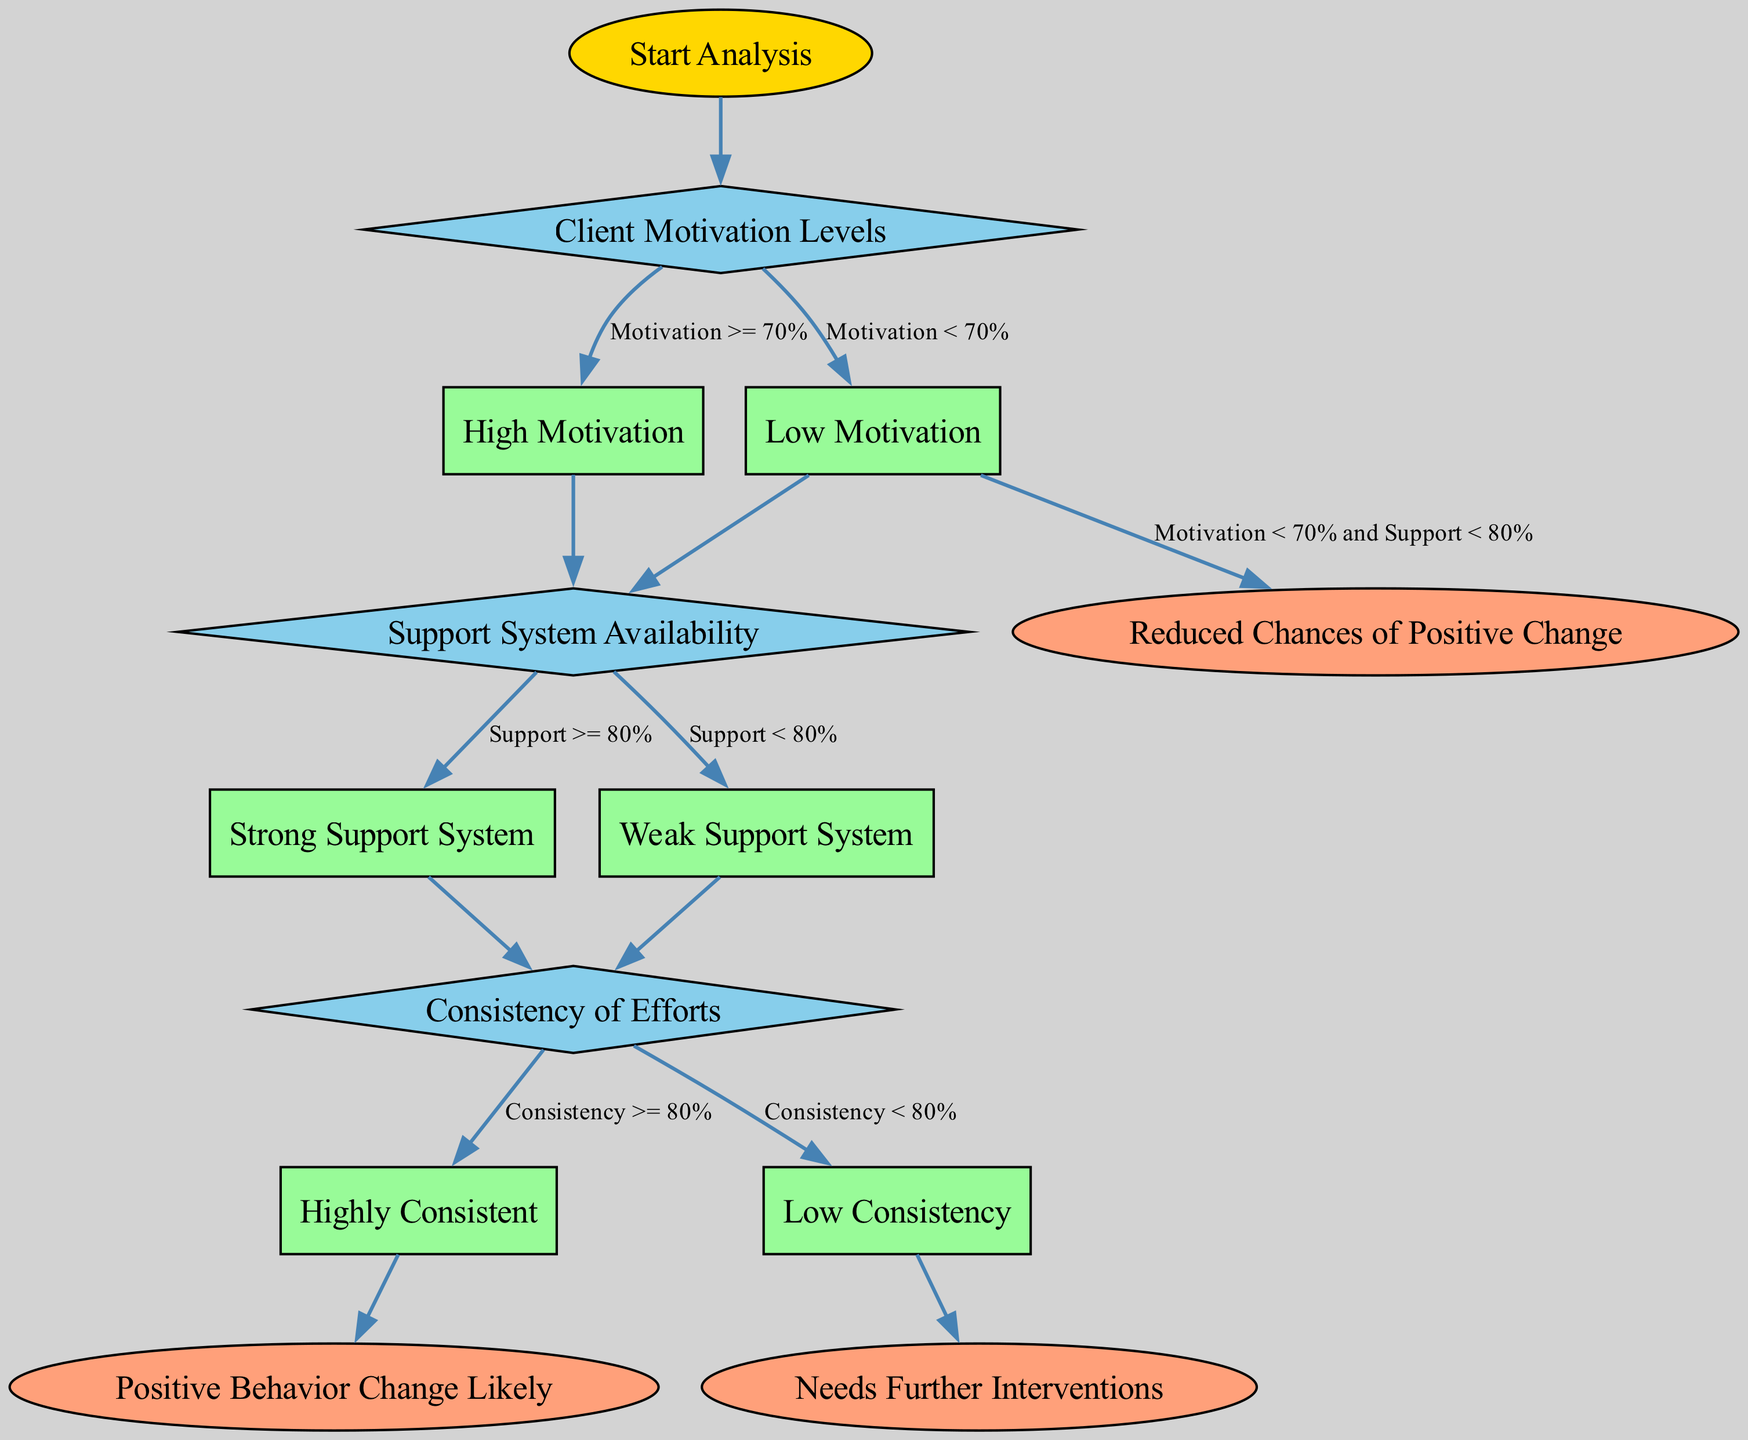What is the root node of the diagram? In the diagram, the root node is where the analysis begins. It is the first node before any decisions are made. Referring to the nodes, the one labeled "Start Analysis" is the root node.
Answer: Start Analysis How many branches are there from the "Client Motivation Levels" decision node? The "Client Motivation Levels" node leads to two branches based on different motivation thresholds. Analyzing the connections, we see it branches into "High Motivation" and "Low Motivation."
Answer: 2 What outcome corresponds to "Highly Consistent"? The "Highly Consistent" branch leads directly to a specific outcome node. Following the edges from "Highly Consistent" in the diagram, we find it leads to the outcome labeled "Positive Behavior Change Likely."
Answer: Positive Behavior Change Likely If client motivation is less than 70% and support is less than 80%, what is the outcome? By examining the branches, when both conditions of low motivation and low support are met, it leads to a specific outcome node. Following this pathway through the diagram, we find it results in "Reduced Chances of Positive Change."
Answer: Reduced Chances of Positive Change What happens at the "Weak Support System" branch? The "Weak Support System" branch leads to a decision point regarding the consistency of efforts, indicating a subsequent step in the analysis. Tracing the edge from "Weak Support System," it goes to the "Consistency of Efforts" decision node.
Answer: Goes to "Consistency of Efforts" decision node What is the condition for transitioning from "Client Motivation Levels" to "Low Motivation"? The condition that dictates this transition is based on the numerical value of client motivation. Specifically, it states that if motivation is less than 70%, the pathway leads to "Low Motivation."
Answer: Motivation < 70% Which node represents the decision about the support system? The node that specifically addresses the availability of the support system is labeled as a decision point. Looking through the decision nodes, the one named "Support System Availability" signifies this decision.
Answer: Support System Availability What outcome arises from "Low Consistency"? Following the branch for "Low Consistency," it leads to an outcome indicating a need for further interventions. Thus, the outcome from this node would be labeled "Needs Further Interventions."
Answer: Needs Further Interventions 